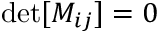<formula> <loc_0><loc_0><loc_500><loc_500>d e t [ M _ { i j } ] = 0</formula> 